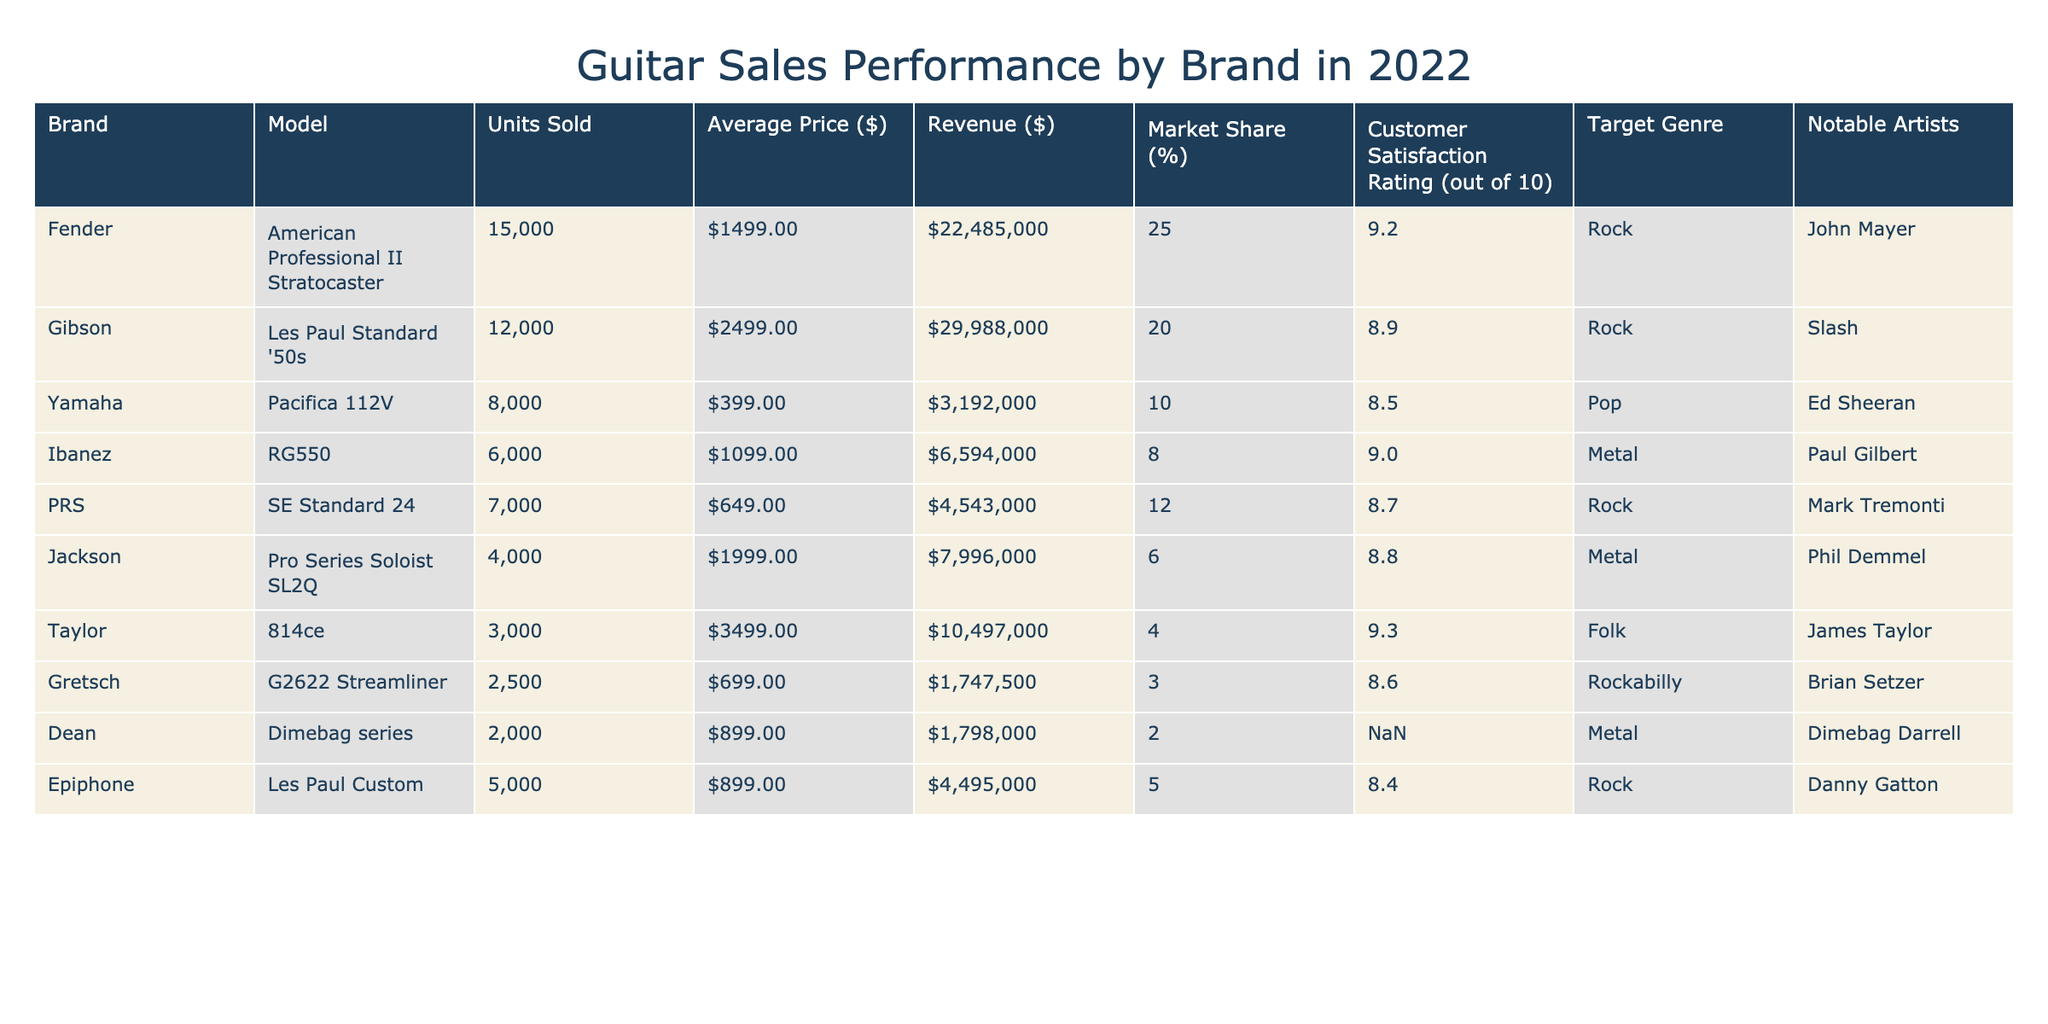What is the brand with the highest units sold? By examining the "Units Sold" column, I can see that the highest value is 15,000, which belongs to the Fender brand.
Answer: Fender What is the average price of the Ibanez RG550? The "Average Price ($)" for the Ibanez RG550 is listed directly in the table as $1,099.
Answer: $1,099 What is the total revenue generated by the top three brands? The total revenue can be calculated by summing the revenues of the top three brands: Fender ($22,485,000) + Gibson ($29,988,000) + Yamaha ($3,192,000) = $55,665,000.
Answer: $55,665,000 Which brand has the highest customer satisfaction rating? Looking at the "Customer Satisfaction Rating (out of 10)" column, the highest rating is 9.3, which belongs to Taylor.
Answer: Taylor Is the average price of the Dean Dimebag series lower than the average price of the PRS SE Standard 24? The average price of the Dean Dimebag series is $899 and the PRS SE Standard 24 is $649. Since $899 is greater than $649, the statement is false.
Answer: No What is the market share percentage of the Gibson Les Paul Standard '50s compared to the Fender American Professional II Stratocaster? Gibson has a market share of 20% while Fender has a market share of 25%. The comparison shows that Fender's market share is 5% higher than Gibson's.
Answer: 5% higher Which genre has the lowest customer satisfaction rating among the brands listed? By analyzing the "Customer Satisfaction Rating" column, the lowest rating is 8.4 associated with the Epiphone Les Paul Custom, which is categorized under Rock.
Answer: Rock How much revenue do Jackson guitars generate compared to Taylor guitars? Jackson generates $7,996,000 while Taylor generates $10,497,000. If we subtract Jackson's revenue from Taylor's, the difference is $2,501,000.
Answer: $2,501,000 Which notable artist is associated with the highest-rated guitar, according to customer satisfaction? The highest rating is 9.3 for the Taylor 814ce, and the notable artist associated with it is James Taylor.
Answer: James Taylor Is the Yamaha Pacifica 112V considered a guitar for the Rock genre? The table specifies that the Yamaha Pacifica 112V is categorized under the Pop genre, hence the statement is false.
Answer: No What is the total number of units sold for brands under the Metal genre? Adding the units sold under the Metal genre: Ibanez (6,000) + Jackson (4,000) + Dean (2,000) = 12,000 units sold in total.
Answer: 12,000 units 